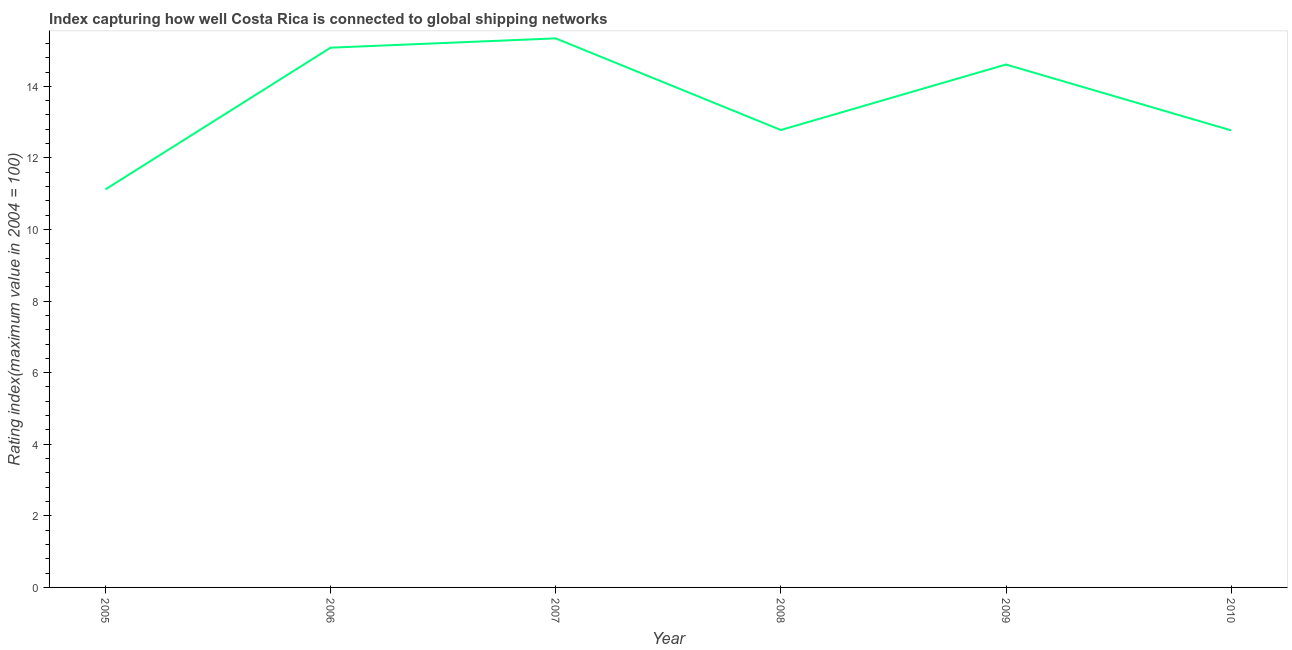What is the liner shipping connectivity index in 2009?
Offer a terse response. 14.61. Across all years, what is the maximum liner shipping connectivity index?
Give a very brief answer. 15.34. Across all years, what is the minimum liner shipping connectivity index?
Provide a succinct answer. 11.12. In which year was the liner shipping connectivity index minimum?
Give a very brief answer. 2005. What is the sum of the liner shipping connectivity index?
Your answer should be very brief. 81.7. What is the difference between the liner shipping connectivity index in 2008 and 2010?
Make the answer very short. 0.01. What is the average liner shipping connectivity index per year?
Ensure brevity in your answer.  13.62. What is the median liner shipping connectivity index?
Provide a short and direct response. 13.7. Do a majority of the years between 2005 and 2007 (inclusive) have liner shipping connectivity index greater than 4.8 ?
Give a very brief answer. Yes. What is the ratio of the liner shipping connectivity index in 2007 to that in 2010?
Provide a succinct answer. 1.2. Is the liner shipping connectivity index in 2006 less than that in 2008?
Your response must be concise. No. Is the difference between the liner shipping connectivity index in 2006 and 2009 greater than the difference between any two years?
Your answer should be very brief. No. What is the difference between the highest and the second highest liner shipping connectivity index?
Your response must be concise. 0.26. What is the difference between the highest and the lowest liner shipping connectivity index?
Ensure brevity in your answer.  4.22. How many years are there in the graph?
Keep it short and to the point. 6. Does the graph contain any zero values?
Offer a terse response. No. What is the title of the graph?
Your answer should be very brief. Index capturing how well Costa Rica is connected to global shipping networks. What is the label or title of the X-axis?
Offer a very short reply. Year. What is the label or title of the Y-axis?
Give a very brief answer. Rating index(maximum value in 2004 = 100). What is the Rating index(maximum value in 2004 = 100) of 2005?
Provide a succinct answer. 11.12. What is the Rating index(maximum value in 2004 = 100) of 2006?
Your response must be concise. 15.08. What is the Rating index(maximum value in 2004 = 100) of 2007?
Your answer should be very brief. 15.34. What is the Rating index(maximum value in 2004 = 100) in 2008?
Your answer should be compact. 12.78. What is the Rating index(maximum value in 2004 = 100) of 2009?
Your response must be concise. 14.61. What is the Rating index(maximum value in 2004 = 100) in 2010?
Your answer should be very brief. 12.77. What is the difference between the Rating index(maximum value in 2004 = 100) in 2005 and 2006?
Offer a terse response. -3.96. What is the difference between the Rating index(maximum value in 2004 = 100) in 2005 and 2007?
Provide a succinct answer. -4.22. What is the difference between the Rating index(maximum value in 2004 = 100) in 2005 and 2008?
Provide a short and direct response. -1.66. What is the difference between the Rating index(maximum value in 2004 = 100) in 2005 and 2009?
Ensure brevity in your answer.  -3.49. What is the difference between the Rating index(maximum value in 2004 = 100) in 2005 and 2010?
Your answer should be very brief. -1.65. What is the difference between the Rating index(maximum value in 2004 = 100) in 2006 and 2007?
Keep it short and to the point. -0.26. What is the difference between the Rating index(maximum value in 2004 = 100) in 2006 and 2009?
Your answer should be compact. 0.47. What is the difference between the Rating index(maximum value in 2004 = 100) in 2006 and 2010?
Provide a short and direct response. 2.31. What is the difference between the Rating index(maximum value in 2004 = 100) in 2007 and 2008?
Provide a short and direct response. 2.56. What is the difference between the Rating index(maximum value in 2004 = 100) in 2007 and 2009?
Offer a very short reply. 0.73. What is the difference between the Rating index(maximum value in 2004 = 100) in 2007 and 2010?
Your answer should be compact. 2.57. What is the difference between the Rating index(maximum value in 2004 = 100) in 2008 and 2009?
Your answer should be very brief. -1.83. What is the difference between the Rating index(maximum value in 2004 = 100) in 2008 and 2010?
Give a very brief answer. 0.01. What is the difference between the Rating index(maximum value in 2004 = 100) in 2009 and 2010?
Provide a succinct answer. 1.84. What is the ratio of the Rating index(maximum value in 2004 = 100) in 2005 to that in 2006?
Offer a very short reply. 0.74. What is the ratio of the Rating index(maximum value in 2004 = 100) in 2005 to that in 2007?
Provide a short and direct response. 0.72. What is the ratio of the Rating index(maximum value in 2004 = 100) in 2005 to that in 2008?
Ensure brevity in your answer.  0.87. What is the ratio of the Rating index(maximum value in 2004 = 100) in 2005 to that in 2009?
Provide a short and direct response. 0.76. What is the ratio of the Rating index(maximum value in 2004 = 100) in 2005 to that in 2010?
Give a very brief answer. 0.87. What is the ratio of the Rating index(maximum value in 2004 = 100) in 2006 to that in 2008?
Your response must be concise. 1.18. What is the ratio of the Rating index(maximum value in 2004 = 100) in 2006 to that in 2009?
Provide a succinct answer. 1.03. What is the ratio of the Rating index(maximum value in 2004 = 100) in 2006 to that in 2010?
Your answer should be very brief. 1.18. What is the ratio of the Rating index(maximum value in 2004 = 100) in 2007 to that in 2008?
Keep it short and to the point. 1.2. What is the ratio of the Rating index(maximum value in 2004 = 100) in 2007 to that in 2010?
Your answer should be compact. 1.2. What is the ratio of the Rating index(maximum value in 2004 = 100) in 2008 to that in 2010?
Make the answer very short. 1. What is the ratio of the Rating index(maximum value in 2004 = 100) in 2009 to that in 2010?
Make the answer very short. 1.14. 